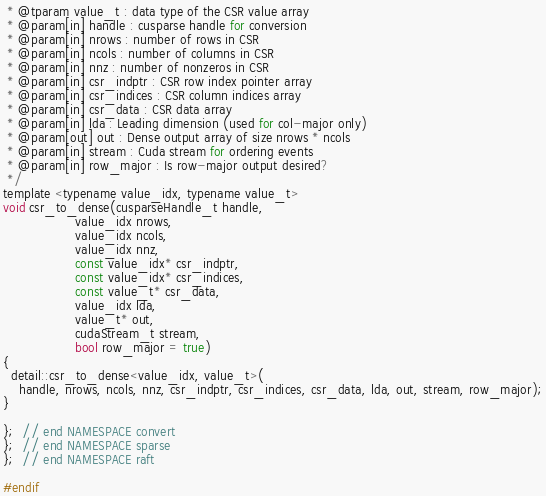Convert code to text. <code><loc_0><loc_0><loc_500><loc_500><_Cuda_> * @tparam value_t : data type of the CSR value array
 * @param[in] handle : cusparse handle for conversion
 * @param[in] nrows : number of rows in CSR
 * @param[in] ncols : number of columns in CSR
 * @param[in] nnz : number of nonzeros in CSR
 * @param[in] csr_indptr : CSR row index pointer array
 * @param[in] csr_indices : CSR column indices array
 * @param[in] csr_data : CSR data array
 * @param[in] lda : Leading dimension (used for col-major only)
 * @param[out] out : Dense output array of size nrows * ncols
 * @param[in] stream : Cuda stream for ordering events
 * @param[in] row_major : Is row-major output desired?
 */
template <typename value_idx, typename value_t>
void csr_to_dense(cusparseHandle_t handle,
                  value_idx nrows,
                  value_idx ncols,
                  value_idx nnz,
                  const value_idx* csr_indptr,
                  const value_idx* csr_indices,
                  const value_t* csr_data,
                  value_idx lda,
                  value_t* out,
                  cudaStream_t stream,
                  bool row_major = true)
{
  detail::csr_to_dense<value_idx, value_t>(
    handle, nrows, ncols, nnz, csr_indptr, csr_indices, csr_data, lda, out, stream, row_major);
}

};  // end NAMESPACE convert
};  // end NAMESPACE sparse
};  // end NAMESPACE raft

#endif</code> 